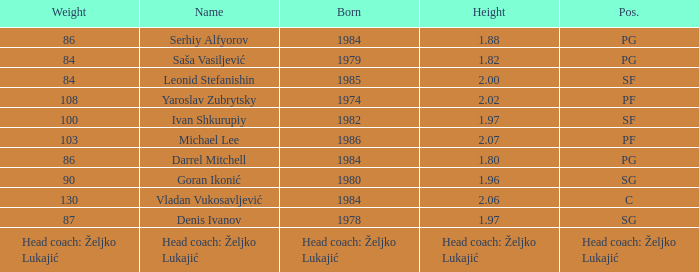What is the weight of the person born in 1980? 90.0. 